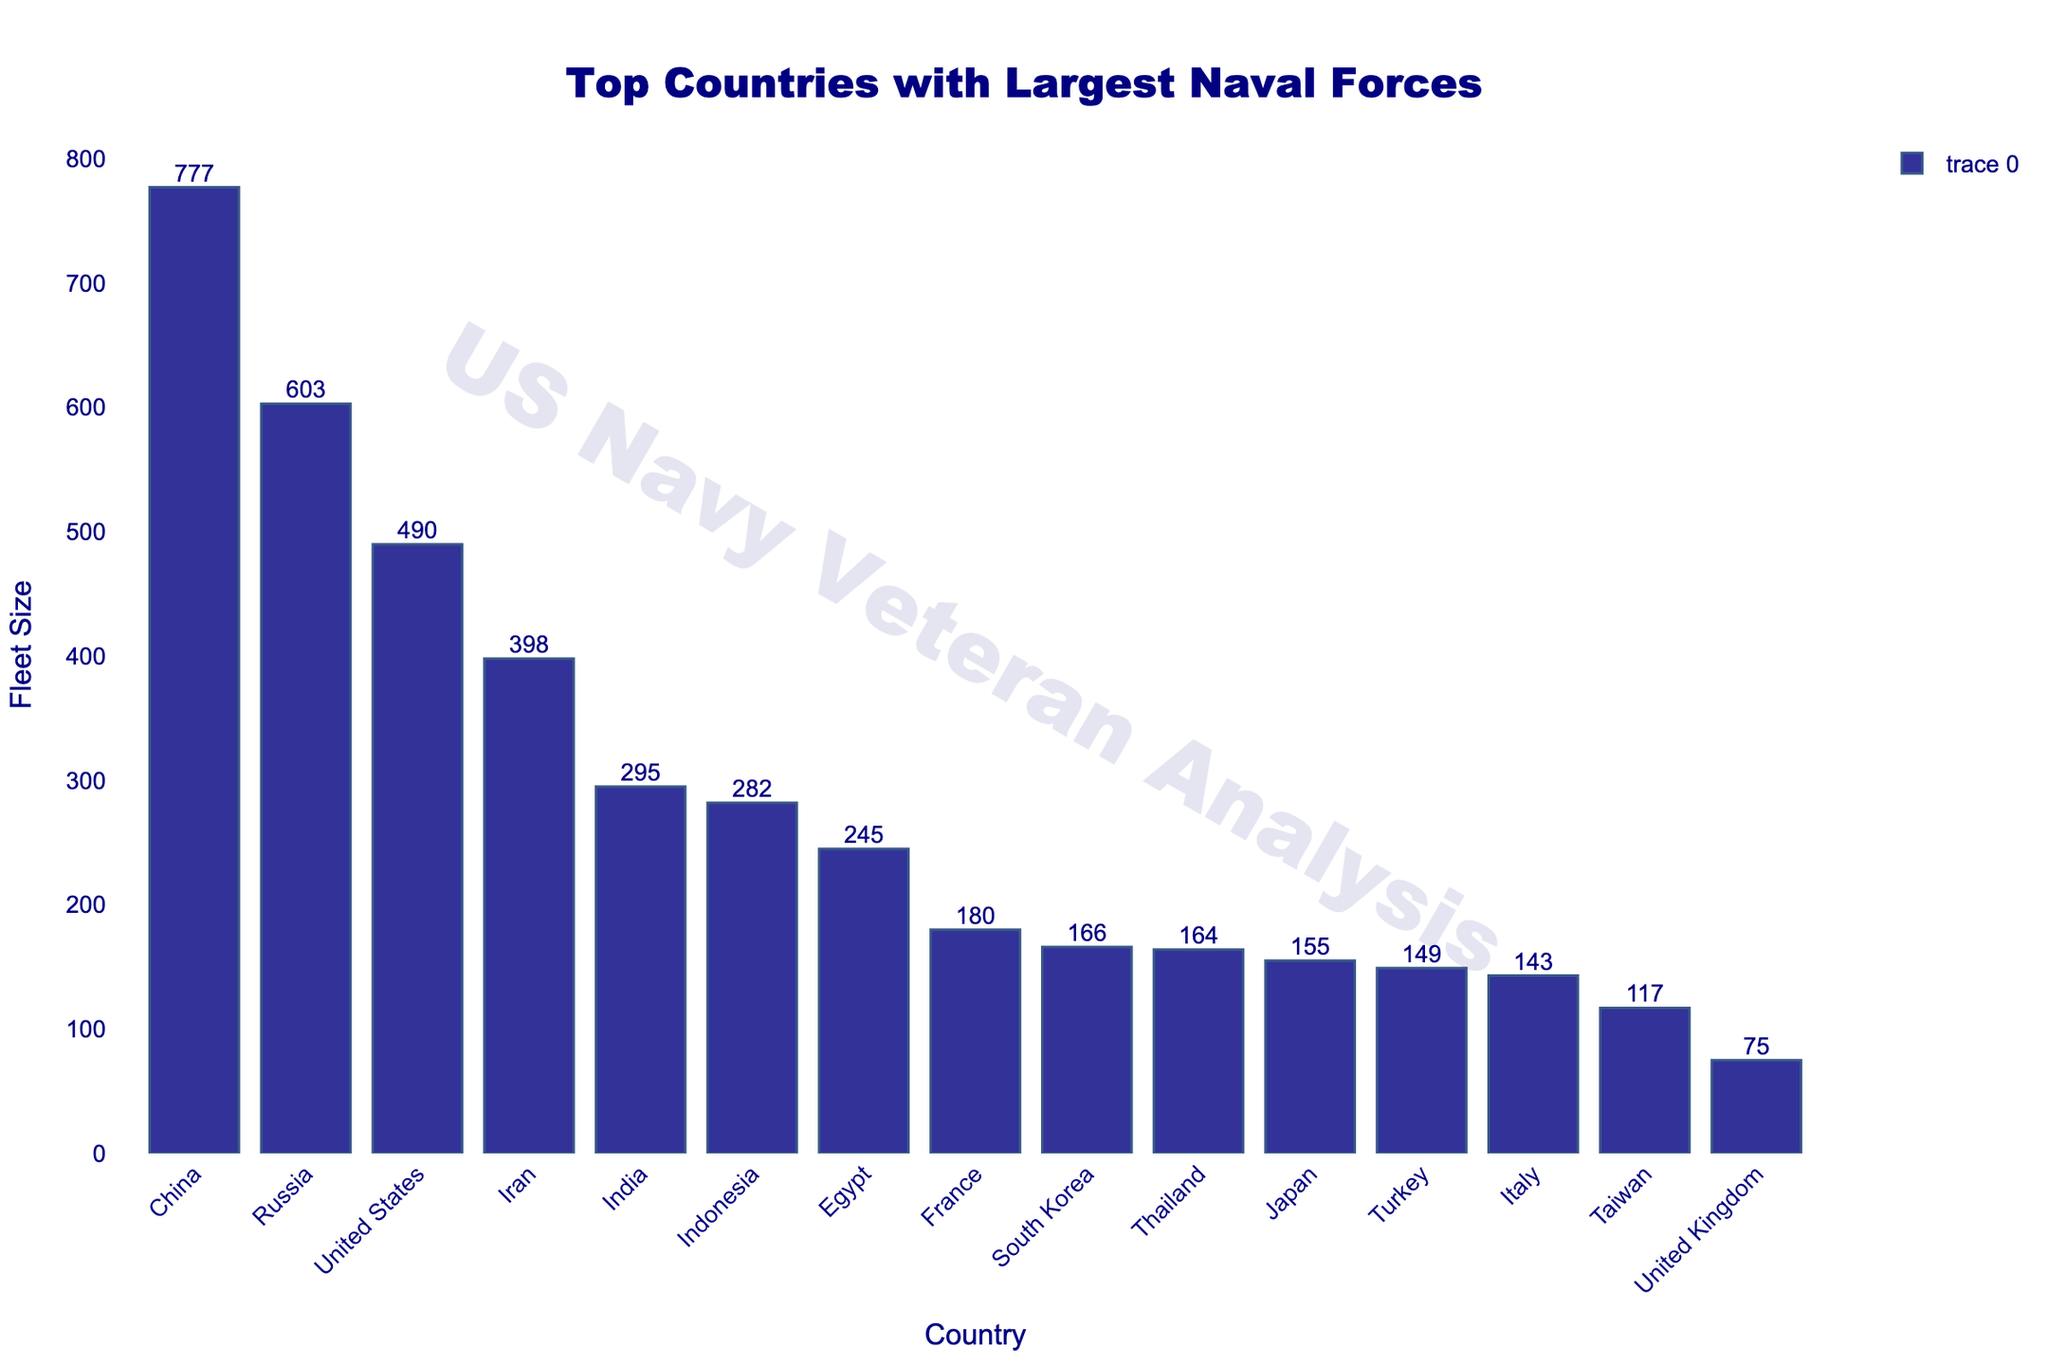Which country has the largest naval fleet? According to the chart, China has the largest naval fleet with 777 ships.
Answer: China Which country has the smallest naval fleet among the top 10 listed? The chart indicates that the United Kingdom has the smallest fleet among the top 10 listed, with 75 ships.
Answer: United Kingdom How many more ships does China have compared to the United States? China has 777 ships, while the United States has 490. The difference is 777 - 490 = 287 ships.
Answer: 287 What is the total fleet size of the top 3 countries combined? The top 3 countries are China, Russia, and the United States with fleet sizes of 777, 603, and 490 respectively. The total is 777 + 603 + 490 = 1870.
Answer: 1870 What is the average fleet size of the top 5 countries? The top 5 countries are China, Russia, the United States, Iran, and India with fleet sizes of 777, 603, 490, 398, and 295 respectively. The total is 777 + 603 + 490 + 398 + 295 = 2563. The average is 2563 / 5 = 512.6.
Answer: 512.6 Which countries have a fleet size greater than 300 ships? From the chart, the countries with fleet sizes greater than 300 ships are China (777), Russia (603), the United States (490), and Iran (398).
Answer: China, Russia, United States, Iran What is the difference in fleet size between India and Indonesia? According to the chart, India has 295 ships and Indonesia has 282 ships. The difference is 295 - 282 = 13 ships.
Answer: 13 How many countries have a fleet size between 100 and 200 ships? The chart shows that Japan (155), South Korea (166), France (180), Thailand (164), and Taiwan (117) have fleet sizes within this range. Therefore, there are 5 countries.
Answer: 5 Compare the fleet size of Turkey and Italy. Which one has a larger fleet? According to the chart, Turkey has 149 ships, while Italy has 143 ships. Therefore, Turkey has a larger fleet.
Answer: Turkey What is the cumulative fleet size for the United Kingdom, France, Italy, and Taiwan? The fleet sizes for these countries are United Kingdom (75), France (180), Italy (143), and Taiwan (117). The cumulative fleet size is 75 + 180 + 143 + 117 = 515.
Answer: 515 